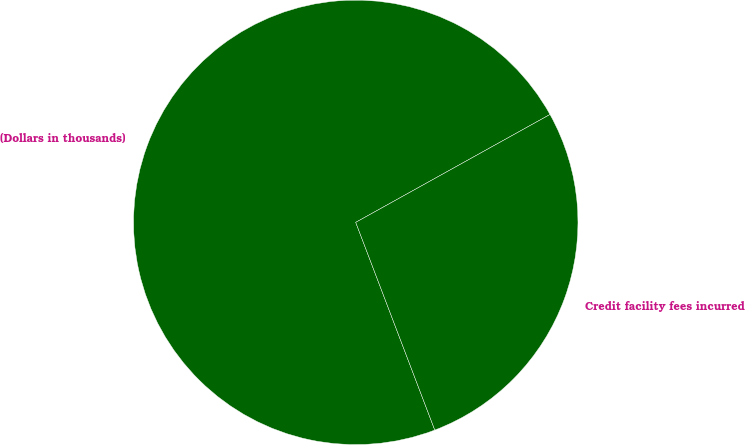Convert chart. <chart><loc_0><loc_0><loc_500><loc_500><pie_chart><fcel>(Dollars in thousands)<fcel>Credit facility fees incurred<nl><fcel>72.72%<fcel>27.28%<nl></chart> 